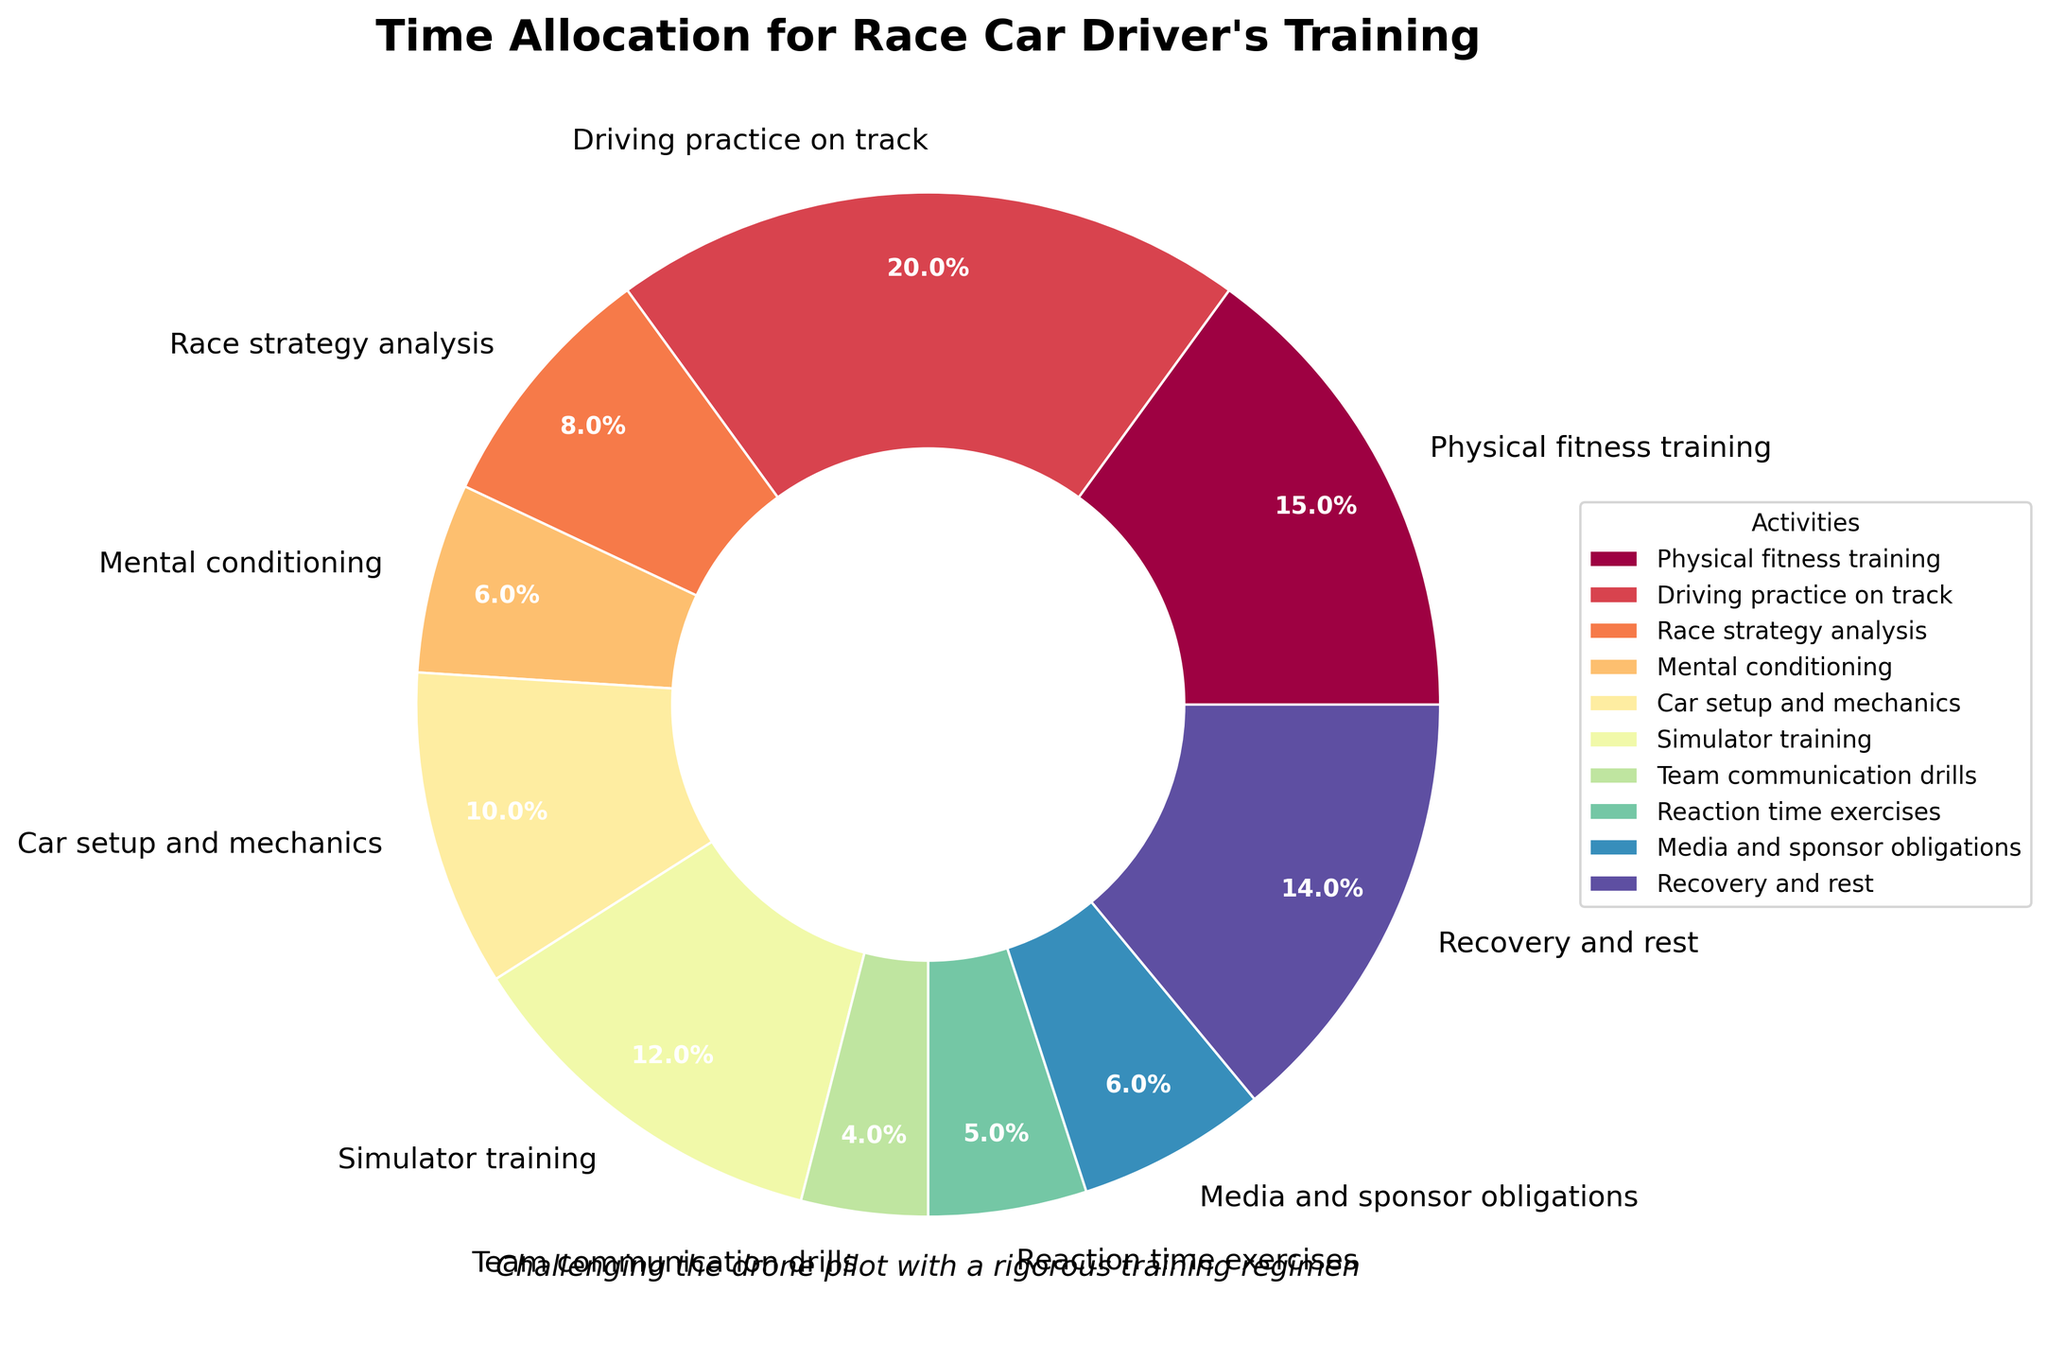Which activity takes the most hours per week? The activity that takes the most hours per week can be identified by finding the largest segment in the pie chart.
Answer: Driving practice on track What percentage of time is spent on physical fitness training? Check the pie chart for the segment labeled "Physical fitness training" and read the percentage value displayed.
Answer: 15.6% How does the time spent on media and sponsor obligations compare to mental conditioning? Compare the percentages of the two activities shown in the pie chart; Media and sponsor obligations is larger.
Answer: Media and sponsor obligations > Mental conditioning What is the total time spent on both simulator training and car setup and mechanics combined? Find the hours for simulator training (12) and car setup and mechanics (10) and sum them up: 12 + 10 = 22 hours per week.
Answer: 22 hours per week How many more hours are spent on recovery and rest than on reaction time exercises? Recovery and rest is 14 hours, and reaction time exercises is 5 hours. Calculate the difference: 14 - 5 = 9 hours.
Answer: 9 hours Is more time spent on race strategy analysis or team communication drills? Identify the segments for each activity and compare their sizes; Race strategy analysis is larger.
Answer: Race strategy analysis What fraction of the total training time is dedicated to recovery and rest? Total hours per week is 100; calculate the fraction for recovery and rest: 14/100 = 0.14.
Answer: 0.14 If time spent on driving practice were reduced by 25%, how many hours would be allocated to it? Calculate 25% of 20 hours (0.25 * 20 = 5), then subtract from the original hours: 20 - 5 = 15 hours.
Answer: 15 hours per week What is the overall percentage of time spent between driving practice, physical fitness training, and mental conditioning combined? Find the percentages for each: Driving practice (20%), Physical fitness (15.6%), Mental conditioning (6.7%). Sum them: 20 + 15.6 + 6.7 = 42.3%.
Answer: 42.3% 